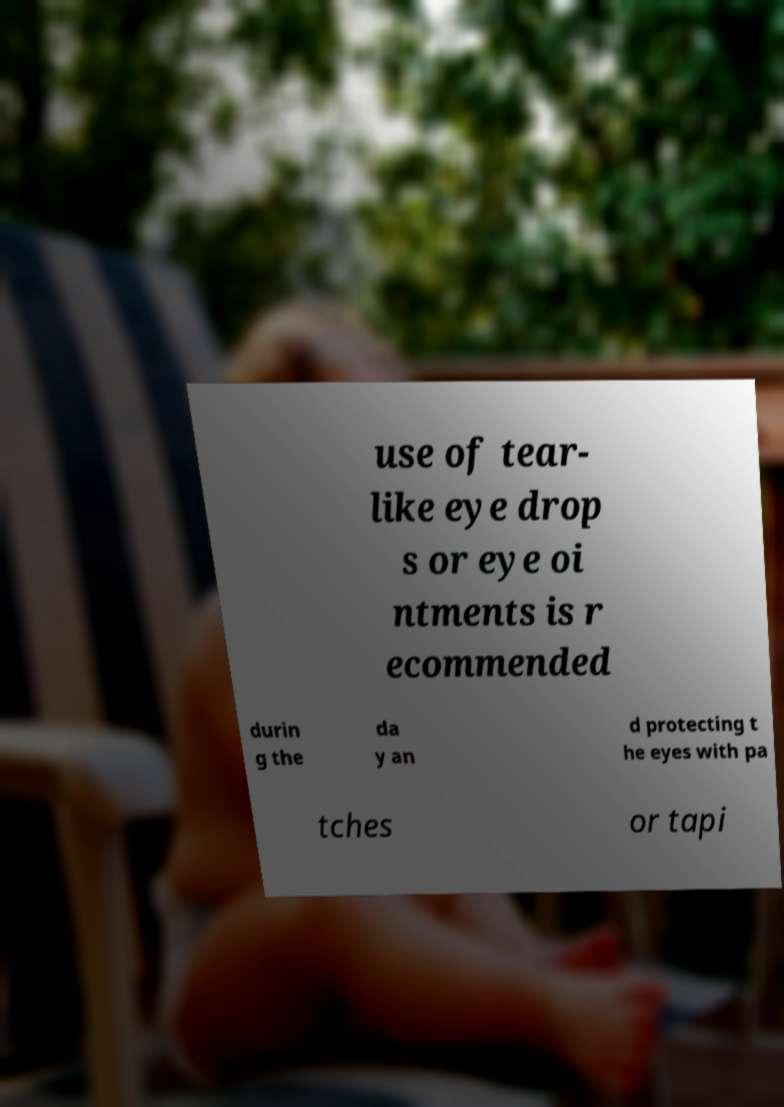What messages or text are displayed in this image? I need them in a readable, typed format. use of tear- like eye drop s or eye oi ntments is r ecommended durin g the da y an d protecting t he eyes with pa tches or tapi 